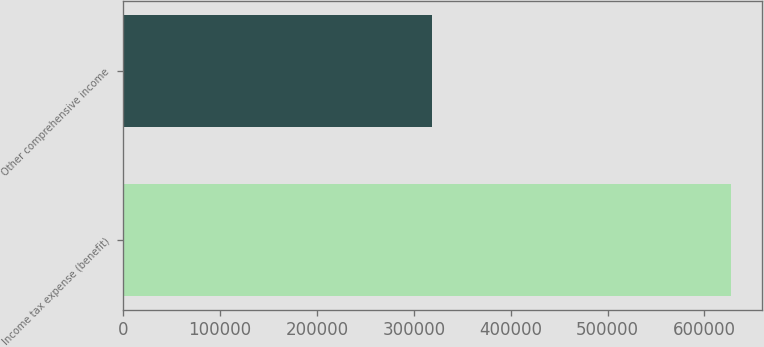<chart> <loc_0><loc_0><loc_500><loc_500><bar_chart><fcel>Income tax expense (benefit)<fcel>Other comprehensive income<nl><fcel>627615<fcel>318475<nl></chart> 